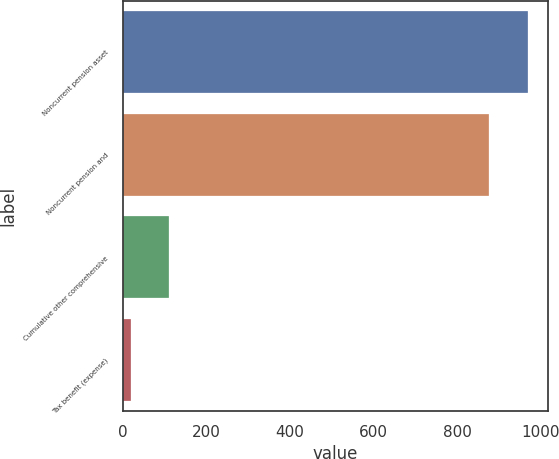Convert chart. <chart><loc_0><loc_0><loc_500><loc_500><bar_chart><fcel>Noncurrent pension asset<fcel>Noncurrent pension and<fcel>Cumulative other comprehensive<fcel>Tax benefit (expense)<nl><fcel>968.7<fcel>877<fcel>111.7<fcel>20<nl></chart> 